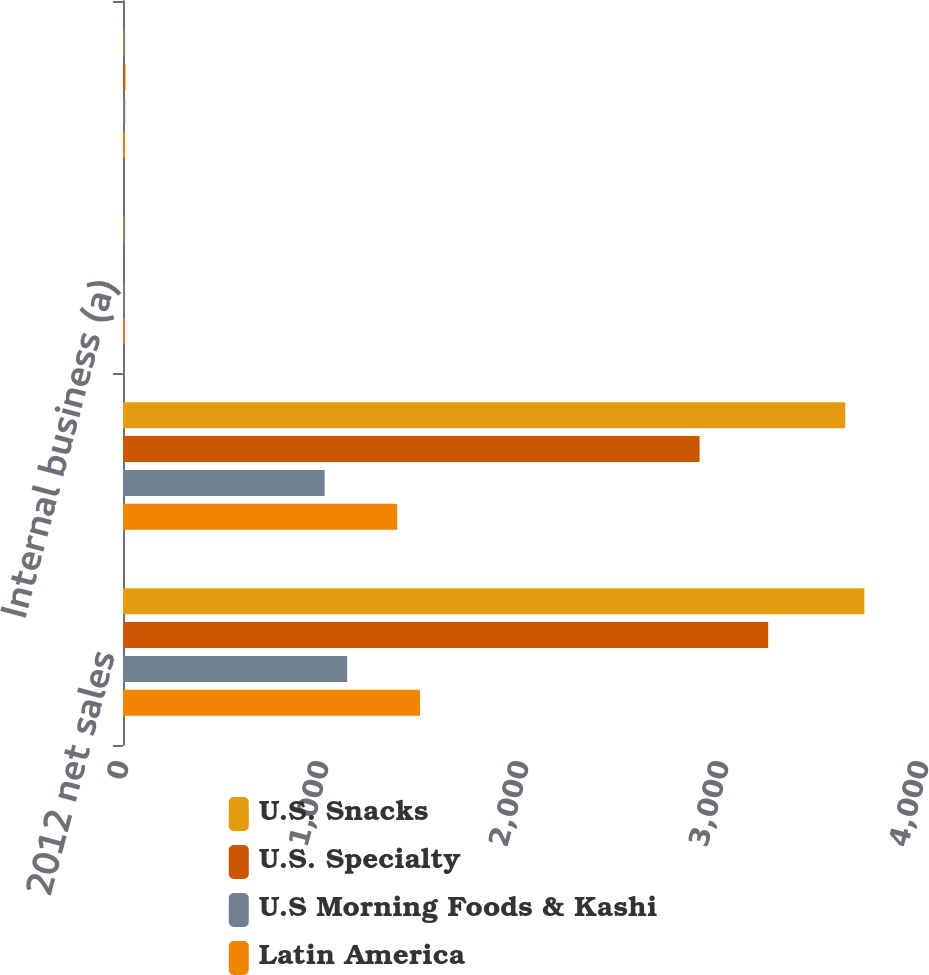<chart> <loc_0><loc_0><loc_500><loc_500><stacked_bar_chart><ecel><fcel>2012 net sales<fcel>2011 net sales<fcel>Internal business (a)<fcel>Total change<nl><fcel>U.S. Snacks<fcel>3707<fcel>3611<fcel>2.7<fcel>2.7<nl><fcel>U.S. Specialty<fcel>3226<fcel>2883<fcel>1.9<fcel>11.9<nl><fcel>U.S Morning Foods & Kashi<fcel>1121<fcel>1008<fcel>7.4<fcel>11.2<nl><fcel>Latin America<fcel>1485<fcel>1371<fcel>7<fcel>8.3<nl></chart> 